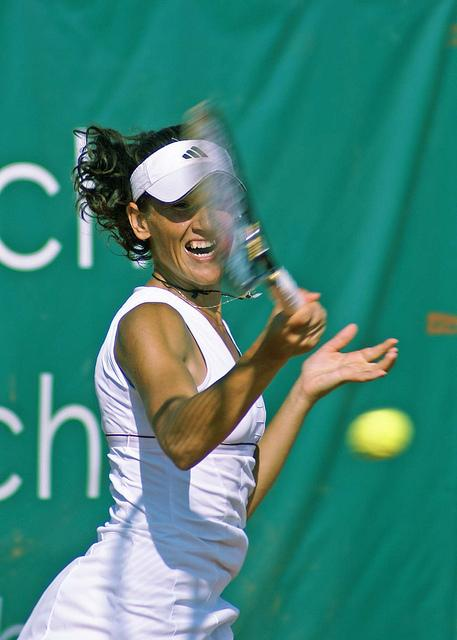Why is the racquet blurred? Please explain your reasoning. rapid motion. The racquet is fast. 